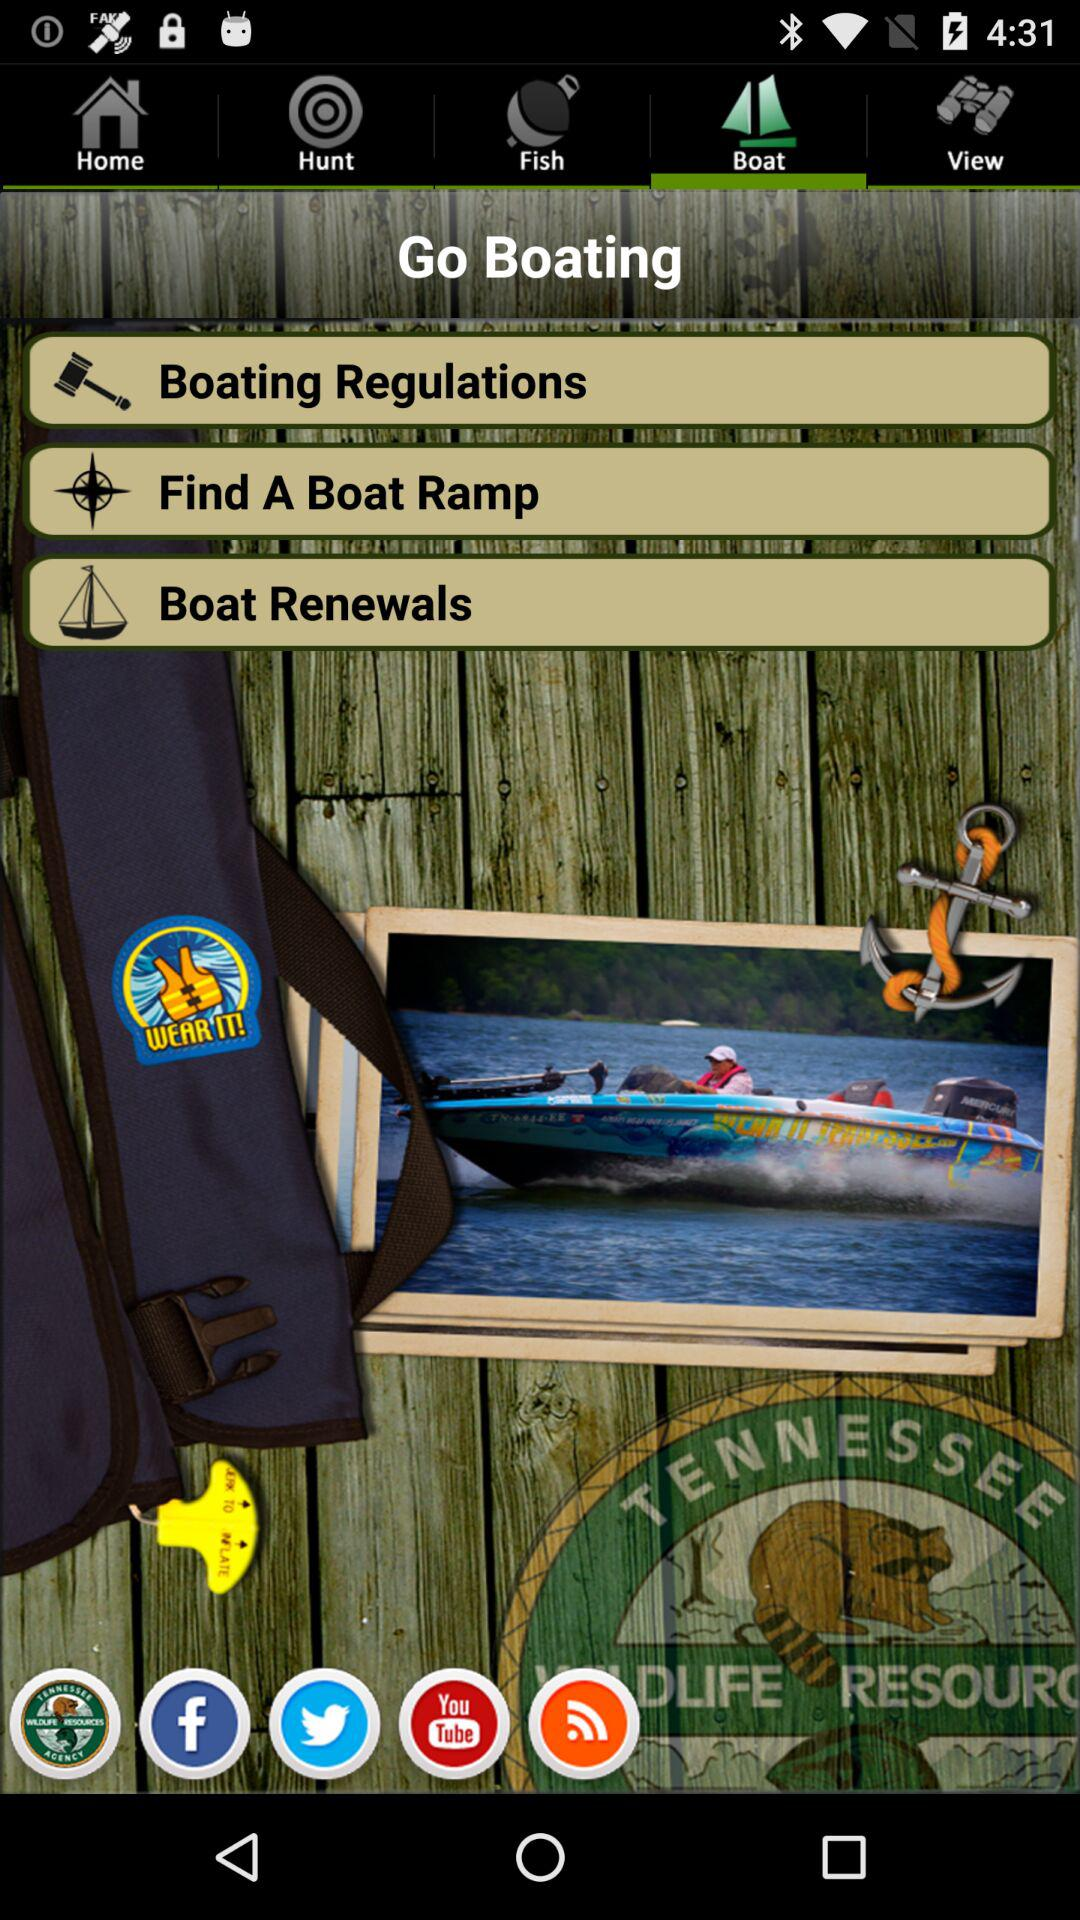Which tab has been selected? The tab that has been selected is "Boat". 